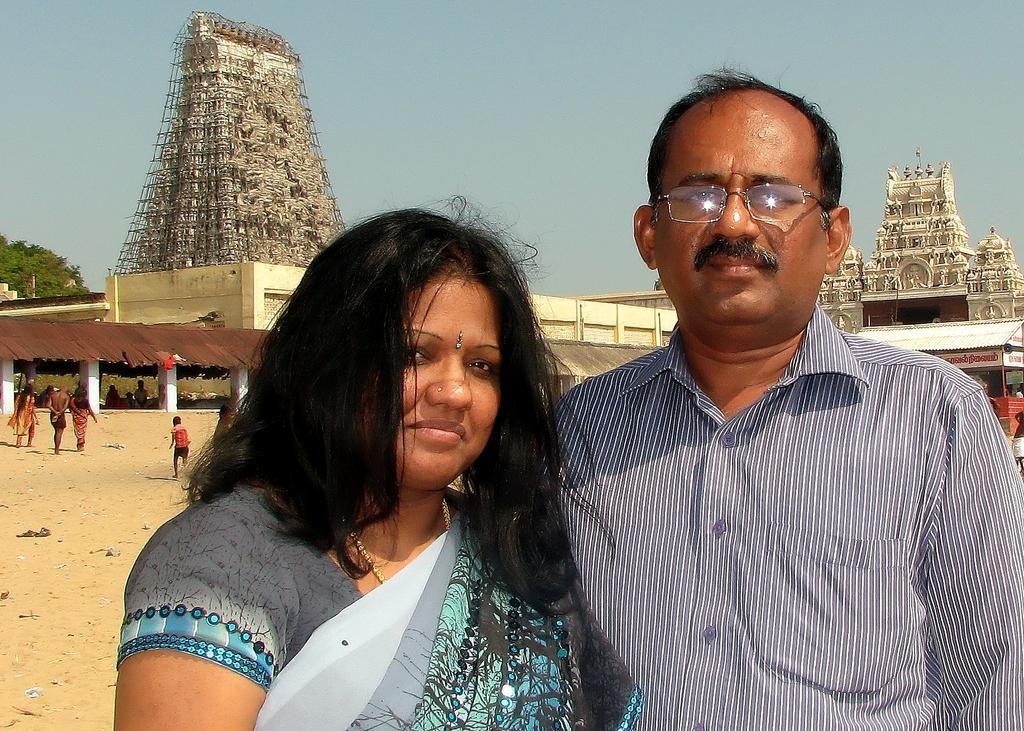Who are the two people standing in the image? There is a man and a woman standing in the image. What can be seen in the background of the image? There are temples visible in the background of the image. What type of vegetation is present in the image? There is a tree in the image. What are some of the activities happening in the image? There are people walking in the image. What is the color of the sky in the image? The sky is blue in the image. Where is the shop located in the image? There is no shop present in the image. What type of worm can be seen crawling on the tree in the image? There are no worms visible in the image, and the tree does not have any visible insects or animals. 